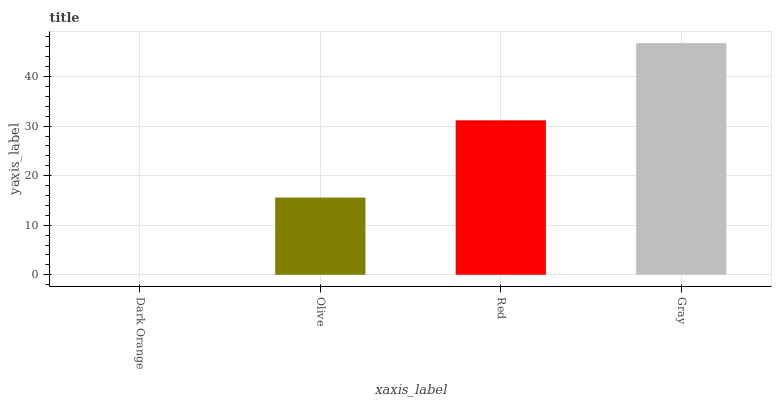Is Olive the minimum?
Answer yes or no. No. Is Olive the maximum?
Answer yes or no. No. Is Olive greater than Dark Orange?
Answer yes or no. Yes. Is Dark Orange less than Olive?
Answer yes or no. Yes. Is Dark Orange greater than Olive?
Answer yes or no. No. Is Olive less than Dark Orange?
Answer yes or no. No. Is Red the high median?
Answer yes or no. Yes. Is Olive the low median?
Answer yes or no. Yes. Is Gray the high median?
Answer yes or no. No. Is Gray the low median?
Answer yes or no. No. 